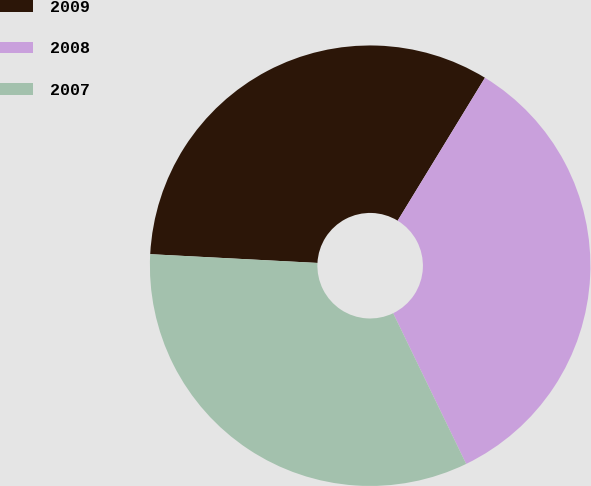<chart> <loc_0><loc_0><loc_500><loc_500><pie_chart><fcel>2009<fcel>2008<fcel>2007<nl><fcel>32.89%<fcel>34.09%<fcel>33.01%<nl></chart> 